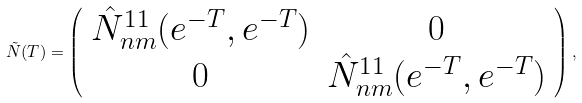Convert formula to latex. <formula><loc_0><loc_0><loc_500><loc_500>\tilde { N } ( T ) = \left ( \begin{array} { c c } \hat { N } ^ { 1 1 } _ { n m } ( e ^ { - T } , e ^ { - T } ) & 0 \\ 0 & \hat { N } ^ { 1 1 } _ { n m } ( e ^ { - T } , e ^ { - T } ) \end{array} \right ) ,</formula> 